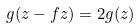Convert formula to latex. <formula><loc_0><loc_0><loc_500><loc_500>g ( z - f z ) = 2 g ( z )</formula> 